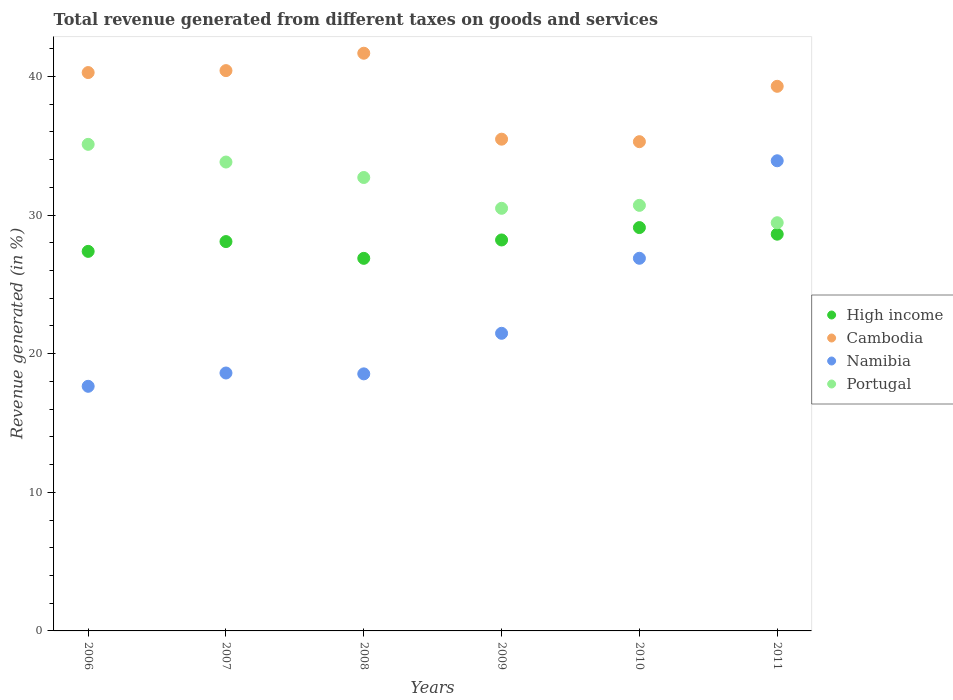Is the number of dotlines equal to the number of legend labels?
Ensure brevity in your answer.  Yes. What is the total revenue generated in High income in 2011?
Give a very brief answer. 28.62. Across all years, what is the maximum total revenue generated in High income?
Offer a very short reply. 29.09. Across all years, what is the minimum total revenue generated in Portugal?
Give a very brief answer. 29.44. In which year was the total revenue generated in High income minimum?
Your answer should be compact. 2008. What is the total total revenue generated in High income in the graph?
Keep it short and to the point. 168.25. What is the difference between the total revenue generated in Portugal in 2008 and that in 2010?
Provide a succinct answer. 2.01. What is the difference between the total revenue generated in High income in 2011 and the total revenue generated in Namibia in 2008?
Offer a terse response. 10.08. What is the average total revenue generated in High income per year?
Offer a terse response. 28.04. In the year 2006, what is the difference between the total revenue generated in High income and total revenue generated in Portugal?
Provide a succinct answer. -7.72. In how many years, is the total revenue generated in Namibia greater than 34 %?
Keep it short and to the point. 0. What is the ratio of the total revenue generated in High income in 2009 to that in 2011?
Your answer should be very brief. 0.99. Is the total revenue generated in Cambodia in 2006 less than that in 2008?
Give a very brief answer. Yes. What is the difference between the highest and the second highest total revenue generated in Portugal?
Give a very brief answer. 1.28. What is the difference between the highest and the lowest total revenue generated in Namibia?
Your response must be concise. 16.27. Is it the case that in every year, the sum of the total revenue generated in Namibia and total revenue generated in Portugal  is greater than the sum of total revenue generated in Cambodia and total revenue generated in High income?
Give a very brief answer. No. Is it the case that in every year, the sum of the total revenue generated in Portugal and total revenue generated in Namibia  is greater than the total revenue generated in High income?
Provide a succinct answer. Yes. How many years are there in the graph?
Your response must be concise. 6. Does the graph contain grids?
Ensure brevity in your answer.  No. How are the legend labels stacked?
Your answer should be very brief. Vertical. What is the title of the graph?
Keep it short and to the point. Total revenue generated from different taxes on goods and services. Does "Japan" appear as one of the legend labels in the graph?
Ensure brevity in your answer.  No. What is the label or title of the X-axis?
Your answer should be very brief. Years. What is the label or title of the Y-axis?
Ensure brevity in your answer.  Revenue generated (in %). What is the Revenue generated (in %) of High income in 2006?
Provide a short and direct response. 27.38. What is the Revenue generated (in %) of Cambodia in 2006?
Your response must be concise. 40.28. What is the Revenue generated (in %) in Namibia in 2006?
Ensure brevity in your answer.  17.65. What is the Revenue generated (in %) in Portugal in 2006?
Your answer should be very brief. 35.1. What is the Revenue generated (in %) in High income in 2007?
Provide a succinct answer. 28.08. What is the Revenue generated (in %) of Cambodia in 2007?
Keep it short and to the point. 40.42. What is the Revenue generated (in %) in Namibia in 2007?
Your response must be concise. 18.6. What is the Revenue generated (in %) of Portugal in 2007?
Provide a succinct answer. 33.82. What is the Revenue generated (in %) in High income in 2008?
Your answer should be very brief. 26.87. What is the Revenue generated (in %) in Cambodia in 2008?
Your answer should be compact. 41.67. What is the Revenue generated (in %) of Namibia in 2008?
Ensure brevity in your answer.  18.54. What is the Revenue generated (in %) of Portugal in 2008?
Give a very brief answer. 32.71. What is the Revenue generated (in %) in High income in 2009?
Offer a terse response. 28.2. What is the Revenue generated (in %) in Cambodia in 2009?
Give a very brief answer. 35.47. What is the Revenue generated (in %) of Namibia in 2009?
Offer a terse response. 21.47. What is the Revenue generated (in %) of Portugal in 2009?
Your answer should be very brief. 30.48. What is the Revenue generated (in %) in High income in 2010?
Make the answer very short. 29.09. What is the Revenue generated (in %) of Cambodia in 2010?
Offer a very short reply. 35.29. What is the Revenue generated (in %) of Namibia in 2010?
Ensure brevity in your answer.  26.88. What is the Revenue generated (in %) of Portugal in 2010?
Give a very brief answer. 30.7. What is the Revenue generated (in %) of High income in 2011?
Keep it short and to the point. 28.62. What is the Revenue generated (in %) of Cambodia in 2011?
Provide a short and direct response. 39.28. What is the Revenue generated (in %) in Namibia in 2011?
Ensure brevity in your answer.  33.91. What is the Revenue generated (in %) of Portugal in 2011?
Provide a succinct answer. 29.44. Across all years, what is the maximum Revenue generated (in %) in High income?
Make the answer very short. 29.09. Across all years, what is the maximum Revenue generated (in %) in Cambodia?
Offer a very short reply. 41.67. Across all years, what is the maximum Revenue generated (in %) of Namibia?
Offer a terse response. 33.91. Across all years, what is the maximum Revenue generated (in %) of Portugal?
Your answer should be very brief. 35.1. Across all years, what is the minimum Revenue generated (in %) in High income?
Give a very brief answer. 26.87. Across all years, what is the minimum Revenue generated (in %) in Cambodia?
Offer a very short reply. 35.29. Across all years, what is the minimum Revenue generated (in %) in Namibia?
Give a very brief answer. 17.65. Across all years, what is the minimum Revenue generated (in %) of Portugal?
Offer a very short reply. 29.44. What is the total Revenue generated (in %) of High income in the graph?
Give a very brief answer. 168.25. What is the total Revenue generated (in %) in Cambodia in the graph?
Ensure brevity in your answer.  232.41. What is the total Revenue generated (in %) in Namibia in the graph?
Ensure brevity in your answer.  137.05. What is the total Revenue generated (in %) of Portugal in the graph?
Offer a very short reply. 192.25. What is the difference between the Revenue generated (in %) of High income in 2006 and that in 2007?
Offer a very short reply. -0.71. What is the difference between the Revenue generated (in %) in Cambodia in 2006 and that in 2007?
Your answer should be very brief. -0.14. What is the difference between the Revenue generated (in %) of Namibia in 2006 and that in 2007?
Your answer should be compact. -0.96. What is the difference between the Revenue generated (in %) in Portugal in 2006 and that in 2007?
Offer a very short reply. 1.28. What is the difference between the Revenue generated (in %) of High income in 2006 and that in 2008?
Your response must be concise. 0.5. What is the difference between the Revenue generated (in %) of Cambodia in 2006 and that in 2008?
Offer a terse response. -1.39. What is the difference between the Revenue generated (in %) of Namibia in 2006 and that in 2008?
Your answer should be very brief. -0.9. What is the difference between the Revenue generated (in %) in Portugal in 2006 and that in 2008?
Your answer should be very brief. 2.39. What is the difference between the Revenue generated (in %) of High income in 2006 and that in 2009?
Offer a very short reply. -0.82. What is the difference between the Revenue generated (in %) of Cambodia in 2006 and that in 2009?
Ensure brevity in your answer.  4.8. What is the difference between the Revenue generated (in %) in Namibia in 2006 and that in 2009?
Your response must be concise. -3.82. What is the difference between the Revenue generated (in %) of Portugal in 2006 and that in 2009?
Give a very brief answer. 4.61. What is the difference between the Revenue generated (in %) in High income in 2006 and that in 2010?
Keep it short and to the point. -1.72. What is the difference between the Revenue generated (in %) of Cambodia in 2006 and that in 2010?
Ensure brevity in your answer.  4.99. What is the difference between the Revenue generated (in %) in Namibia in 2006 and that in 2010?
Offer a very short reply. -9.23. What is the difference between the Revenue generated (in %) in Portugal in 2006 and that in 2010?
Your answer should be very brief. 4.4. What is the difference between the Revenue generated (in %) of High income in 2006 and that in 2011?
Provide a short and direct response. -1.24. What is the difference between the Revenue generated (in %) of Cambodia in 2006 and that in 2011?
Offer a very short reply. 0.99. What is the difference between the Revenue generated (in %) in Namibia in 2006 and that in 2011?
Your answer should be very brief. -16.27. What is the difference between the Revenue generated (in %) in Portugal in 2006 and that in 2011?
Make the answer very short. 5.65. What is the difference between the Revenue generated (in %) of High income in 2007 and that in 2008?
Give a very brief answer. 1.21. What is the difference between the Revenue generated (in %) in Cambodia in 2007 and that in 2008?
Make the answer very short. -1.25. What is the difference between the Revenue generated (in %) of Namibia in 2007 and that in 2008?
Keep it short and to the point. 0.06. What is the difference between the Revenue generated (in %) in Portugal in 2007 and that in 2008?
Ensure brevity in your answer.  1.12. What is the difference between the Revenue generated (in %) in High income in 2007 and that in 2009?
Make the answer very short. -0.12. What is the difference between the Revenue generated (in %) in Cambodia in 2007 and that in 2009?
Keep it short and to the point. 4.95. What is the difference between the Revenue generated (in %) in Namibia in 2007 and that in 2009?
Give a very brief answer. -2.86. What is the difference between the Revenue generated (in %) in Portugal in 2007 and that in 2009?
Ensure brevity in your answer.  3.34. What is the difference between the Revenue generated (in %) in High income in 2007 and that in 2010?
Provide a succinct answer. -1.01. What is the difference between the Revenue generated (in %) in Cambodia in 2007 and that in 2010?
Provide a short and direct response. 5.13. What is the difference between the Revenue generated (in %) of Namibia in 2007 and that in 2010?
Ensure brevity in your answer.  -8.28. What is the difference between the Revenue generated (in %) in Portugal in 2007 and that in 2010?
Your answer should be very brief. 3.12. What is the difference between the Revenue generated (in %) of High income in 2007 and that in 2011?
Your answer should be compact. -0.53. What is the difference between the Revenue generated (in %) in Cambodia in 2007 and that in 2011?
Make the answer very short. 1.13. What is the difference between the Revenue generated (in %) in Namibia in 2007 and that in 2011?
Offer a terse response. -15.31. What is the difference between the Revenue generated (in %) in Portugal in 2007 and that in 2011?
Your answer should be compact. 4.38. What is the difference between the Revenue generated (in %) in High income in 2008 and that in 2009?
Offer a terse response. -1.33. What is the difference between the Revenue generated (in %) in Cambodia in 2008 and that in 2009?
Provide a succinct answer. 6.2. What is the difference between the Revenue generated (in %) of Namibia in 2008 and that in 2009?
Ensure brevity in your answer.  -2.93. What is the difference between the Revenue generated (in %) in Portugal in 2008 and that in 2009?
Your answer should be compact. 2.22. What is the difference between the Revenue generated (in %) of High income in 2008 and that in 2010?
Offer a very short reply. -2.22. What is the difference between the Revenue generated (in %) in Cambodia in 2008 and that in 2010?
Offer a terse response. 6.38. What is the difference between the Revenue generated (in %) of Namibia in 2008 and that in 2010?
Ensure brevity in your answer.  -8.34. What is the difference between the Revenue generated (in %) of Portugal in 2008 and that in 2010?
Provide a succinct answer. 2.01. What is the difference between the Revenue generated (in %) in High income in 2008 and that in 2011?
Make the answer very short. -1.74. What is the difference between the Revenue generated (in %) in Cambodia in 2008 and that in 2011?
Offer a very short reply. 2.39. What is the difference between the Revenue generated (in %) of Namibia in 2008 and that in 2011?
Your answer should be compact. -15.37. What is the difference between the Revenue generated (in %) of Portugal in 2008 and that in 2011?
Keep it short and to the point. 3.26. What is the difference between the Revenue generated (in %) of High income in 2009 and that in 2010?
Offer a very short reply. -0.89. What is the difference between the Revenue generated (in %) in Cambodia in 2009 and that in 2010?
Your response must be concise. 0.18. What is the difference between the Revenue generated (in %) of Namibia in 2009 and that in 2010?
Provide a short and direct response. -5.41. What is the difference between the Revenue generated (in %) of Portugal in 2009 and that in 2010?
Your answer should be very brief. -0.21. What is the difference between the Revenue generated (in %) of High income in 2009 and that in 2011?
Ensure brevity in your answer.  -0.42. What is the difference between the Revenue generated (in %) in Cambodia in 2009 and that in 2011?
Ensure brevity in your answer.  -3.81. What is the difference between the Revenue generated (in %) of Namibia in 2009 and that in 2011?
Offer a terse response. -12.44. What is the difference between the Revenue generated (in %) in Portugal in 2009 and that in 2011?
Offer a very short reply. 1.04. What is the difference between the Revenue generated (in %) of High income in 2010 and that in 2011?
Your answer should be compact. 0.48. What is the difference between the Revenue generated (in %) in Cambodia in 2010 and that in 2011?
Give a very brief answer. -3.99. What is the difference between the Revenue generated (in %) of Namibia in 2010 and that in 2011?
Your answer should be very brief. -7.03. What is the difference between the Revenue generated (in %) in Portugal in 2010 and that in 2011?
Make the answer very short. 1.25. What is the difference between the Revenue generated (in %) in High income in 2006 and the Revenue generated (in %) in Cambodia in 2007?
Provide a succinct answer. -13.04. What is the difference between the Revenue generated (in %) of High income in 2006 and the Revenue generated (in %) of Namibia in 2007?
Make the answer very short. 8.77. What is the difference between the Revenue generated (in %) of High income in 2006 and the Revenue generated (in %) of Portugal in 2007?
Offer a very short reply. -6.44. What is the difference between the Revenue generated (in %) of Cambodia in 2006 and the Revenue generated (in %) of Namibia in 2007?
Offer a very short reply. 21.67. What is the difference between the Revenue generated (in %) of Cambodia in 2006 and the Revenue generated (in %) of Portugal in 2007?
Offer a very short reply. 6.45. What is the difference between the Revenue generated (in %) of Namibia in 2006 and the Revenue generated (in %) of Portugal in 2007?
Provide a short and direct response. -16.18. What is the difference between the Revenue generated (in %) in High income in 2006 and the Revenue generated (in %) in Cambodia in 2008?
Ensure brevity in your answer.  -14.29. What is the difference between the Revenue generated (in %) of High income in 2006 and the Revenue generated (in %) of Namibia in 2008?
Ensure brevity in your answer.  8.84. What is the difference between the Revenue generated (in %) in High income in 2006 and the Revenue generated (in %) in Portugal in 2008?
Your answer should be very brief. -5.33. What is the difference between the Revenue generated (in %) in Cambodia in 2006 and the Revenue generated (in %) in Namibia in 2008?
Offer a very short reply. 21.73. What is the difference between the Revenue generated (in %) of Cambodia in 2006 and the Revenue generated (in %) of Portugal in 2008?
Ensure brevity in your answer.  7.57. What is the difference between the Revenue generated (in %) in Namibia in 2006 and the Revenue generated (in %) in Portugal in 2008?
Make the answer very short. -15.06. What is the difference between the Revenue generated (in %) in High income in 2006 and the Revenue generated (in %) in Cambodia in 2009?
Offer a terse response. -8.09. What is the difference between the Revenue generated (in %) in High income in 2006 and the Revenue generated (in %) in Namibia in 2009?
Provide a short and direct response. 5.91. What is the difference between the Revenue generated (in %) in High income in 2006 and the Revenue generated (in %) in Portugal in 2009?
Your response must be concise. -3.11. What is the difference between the Revenue generated (in %) in Cambodia in 2006 and the Revenue generated (in %) in Namibia in 2009?
Offer a very short reply. 18.81. What is the difference between the Revenue generated (in %) in Cambodia in 2006 and the Revenue generated (in %) in Portugal in 2009?
Keep it short and to the point. 9.79. What is the difference between the Revenue generated (in %) in Namibia in 2006 and the Revenue generated (in %) in Portugal in 2009?
Provide a succinct answer. -12.84. What is the difference between the Revenue generated (in %) of High income in 2006 and the Revenue generated (in %) of Cambodia in 2010?
Keep it short and to the point. -7.91. What is the difference between the Revenue generated (in %) of High income in 2006 and the Revenue generated (in %) of Namibia in 2010?
Provide a succinct answer. 0.5. What is the difference between the Revenue generated (in %) of High income in 2006 and the Revenue generated (in %) of Portugal in 2010?
Your answer should be compact. -3.32. What is the difference between the Revenue generated (in %) in Cambodia in 2006 and the Revenue generated (in %) in Namibia in 2010?
Provide a succinct answer. 13.4. What is the difference between the Revenue generated (in %) in Cambodia in 2006 and the Revenue generated (in %) in Portugal in 2010?
Give a very brief answer. 9.58. What is the difference between the Revenue generated (in %) in Namibia in 2006 and the Revenue generated (in %) in Portugal in 2010?
Provide a succinct answer. -13.05. What is the difference between the Revenue generated (in %) in High income in 2006 and the Revenue generated (in %) in Cambodia in 2011?
Make the answer very short. -11.91. What is the difference between the Revenue generated (in %) of High income in 2006 and the Revenue generated (in %) of Namibia in 2011?
Give a very brief answer. -6.54. What is the difference between the Revenue generated (in %) in High income in 2006 and the Revenue generated (in %) in Portugal in 2011?
Your response must be concise. -2.07. What is the difference between the Revenue generated (in %) of Cambodia in 2006 and the Revenue generated (in %) of Namibia in 2011?
Keep it short and to the point. 6.36. What is the difference between the Revenue generated (in %) of Cambodia in 2006 and the Revenue generated (in %) of Portugal in 2011?
Offer a very short reply. 10.83. What is the difference between the Revenue generated (in %) of Namibia in 2006 and the Revenue generated (in %) of Portugal in 2011?
Ensure brevity in your answer.  -11.8. What is the difference between the Revenue generated (in %) in High income in 2007 and the Revenue generated (in %) in Cambodia in 2008?
Offer a very short reply. -13.59. What is the difference between the Revenue generated (in %) in High income in 2007 and the Revenue generated (in %) in Namibia in 2008?
Your answer should be compact. 9.54. What is the difference between the Revenue generated (in %) in High income in 2007 and the Revenue generated (in %) in Portugal in 2008?
Give a very brief answer. -4.62. What is the difference between the Revenue generated (in %) in Cambodia in 2007 and the Revenue generated (in %) in Namibia in 2008?
Keep it short and to the point. 21.87. What is the difference between the Revenue generated (in %) in Cambodia in 2007 and the Revenue generated (in %) in Portugal in 2008?
Your response must be concise. 7.71. What is the difference between the Revenue generated (in %) in Namibia in 2007 and the Revenue generated (in %) in Portugal in 2008?
Ensure brevity in your answer.  -14.1. What is the difference between the Revenue generated (in %) in High income in 2007 and the Revenue generated (in %) in Cambodia in 2009?
Offer a very short reply. -7.39. What is the difference between the Revenue generated (in %) in High income in 2007 and the Revenue generated (in %) in Namibia in 2009?
Make the answer very short. 6.62. What is the difference between the Revenue generated (in %) in High income in 2007 and the Revenue generated (in %) in Portugal in 2009?
Ensure brevity in your answer.  -2.4. What is the difference between the Revenue generated (in %) in Cambodia in 2007 and the Revenue generated (in %) in Namibia in 2009?
Keep it short and to the point. 18.95. What is the difference between the Revenue generated (in %) in Cambodia in 2007 and the Revenue generated (in %) in Portugal in 2009?
Your answer should be compact. 9.93. What is the difference between the Revenue generated (in %) in Namibia in 2007 and the Revenue generated (in %) in Portugal in 2009?
Provide a short and direct response. -11.88. What is the difference between the Revenue generated (in %) of High income in 2007 and the Revenue generated (in %) of Cambodia in 2010?
Ensure brevity in your answer.  -7.21. What is the difference between the Revenue generated (in %) of High income in 2007 and the Revenue generated (in %) of Namibia in 2010?
Give a very brief answer. 1.2. What is the difference between the Revenue generated (in %) in High income in 2007 and the Revenue generated (in %) in Portugal in 2010?
Offer a very short reply. -2.61. What is the difference between the Revenue generated (in %) in Cambodia in 2007 and the Revenue generated (in %) in Namibia in 2010?
Offer a terse response. 13.54. What is the difference between the Revenue generated (in %) of Cambodia in 2007 and the Revenue generated (in %) of Portugal in 2010?
Offer a terse response. 9.72. What is the difference between the Revenue generated (in %) of Namibia in 2007 and the Revenue generated (in %) of Portugal in 2010?
Ensure brevity in your answer.  -12.09. What is the difference between the Revenue generated (in %) in High income in 2007 and the Revenue generated (in %) in Cambodia in 2011?
Keep it short and to the point. -11.2. What is the difference between the Revenue generated (in %) of High income in 2007 and the Revenue generated (in %) of Namibia in 2011?
Offer a terse response. -5.83. What is the difference between the Revenue generated (in %) of High income in 2007 and the Revenue generated (in %) of Portugal in 2011?
Provide a short and direct response. -1.36. What is the difference between the Revenue generated (in %) in Cambodia in 2007 and the Revenue generated (in %) in Namibia in 2011?
Your answer should be very brief. 6.5. What is the difference between the Revenue generated (in %) of Cambodia in 2007 and the Revenue generated (in %) of Portugal in 2011?
Your answer should be very brief. 10.97. What is the difference between the Revenue generated (in %) of Namibia in 2007 and the Revenue generated (in %) of Portugal in 2011?
Give a very brief answer. -10.84. What is the difference between the Revenue generated (in %) in High income in 2008 and the Revenue generated (in %) in Cambodia in 2009?
Provide a succinct answer. -8.6. What is the difference between the Revenue generated (in %) in High income in 2008 and the Revenue generated (in %) in Namibia in 2009?
Provide a short and direct response. 5.41. What is the difference between the Revenue generated (in %) in High income in 2008 and the Revenue generated (in %) in Portugal in 2009?
Make the answer very short. -3.61. What is the difference between the Revenue generated (in %) in Cambodia in 2008 and the Revenue generated (in %) in Namibia in 2009?
Keep it short and to the point. 20.2. What is the difference between the Revenue generated (in %) of Cambodia in 2008 and the Revenue generated (in %) of Portugal in 2009?
Keep it short and to the point. 11.19. What is the difference between the Revenue generated (in %) in Namibia in 2008 and the Revenue generated (in %) in Portugal in 2009?
Your response must be concise. -11.94. What is the difference between the Revenue generated (in %) in High income in 2008 and the Revenue generated (in %) in Cambodia in 2010?
Offer a terse response. -8.42. What is the difference between the Revenue generated (in %) of High income in 2008 and the Revenue generated (in %) of Namibia in 2010?
Provide a short and direct response. -0.01. What is the difference between the Revenue generated (in %) of High income in 2008 and the Revenue generated (in %) of Portugal in 2010?
Keep it short and to the point. -3.82. What is the difference between the Revenue generated (in %) of Cambodia in 2008 and the Revenue generated (in %) of Namibia in 2010?
Make the answer very short. 14.79. What is the difference between the Revenue generated (in %) in Cambodia in 2008 and the Revenue generated (in %) in Portugal in 2010?
Keep it short and to the point. 10.97. What is the difference between the Revenue generated (in %) in Namibia in 2008 and the Revenue generated (in %) in Portugal in 2010?
Your answer should be compact. -12.16. What is the difference between the Revenue generated (in %) of High income in 2008 and the Revenue generated (in %) of Cambodia in 2011?
Offer a very short reply. -12.41. What is the difference between the Revenue generated (in %) in High income in 2008 and the Revenue generated (in %) in Namibia in 2011?
Your answer should be very brief. -7.04. What is the difference between the Revenue generated (in %) in High income in 2008 and the Revenue generated (in %) in Portugal in 2011?
Make the answer very short. -2.57. What is the difference between the Revenue generated (in %) in Cambodia in 2008 and the Revenue generated (in %) in Namibia in 2011?
Offer a very short reply. 7.76. What is the difference between the Revenue generated (in %) of Cambodia in 2008 and the Revenue generated (in %) of Portugal in 2011?
Provide a short and direct response. 12.23. What is the difference between the Revenue generated (in %) in Namibia in 2008 and the Revenue generated (in %) in Portugal in 2011?
Provide a short and direct response. -10.9. What is the difference between the Revenue generated (in %) in High income in 2009 and the Revenue generated (in %) in Cambodia in 2010?
Provide a succinct answer. -7.09. What is the difference between the Revenue generated (in %) of High income in 2009 and the Revenue generated (in %) of Namibia in 2010?
Offer a very short reply. 1.32. What is the difference between the Revenue generated (in %) of High income in 2009 and the Revenue generated (in %) of Portugal in 2010?
Your answer should be compact. -2.5. What is the difference between the Revenue generated (in %) of Cambodia in 2009 and the Revenue generated (in %) of Namibia in 2010?
Provide a short and direct response. 8.59. What is the difference between the Revenue generated (in %) in Cambodia in 2009 and the Revenue generated (in %) in Portugal in 2010?
Provide a short and direct response. 4.77. What is the difference between the Revenue generated (in %) in Namibia in 2009 and the Revenue generated (in %) in Portugal in 2010?
Your answer should be very brief. -9.23. What is the difference between the Revenue generated (in %) of High income in 2009 and the Revenue generated (in %) of Cambodia in 2011?
Offer a terse response. -11.08. What is the difference between the Revenue generated (in %) in High income in 2009 and the Revenue generated (in %) in Namibia in 2011?
Give a very brief answer. -5.71. What is the difference between the Revenue generated (in %) in High income in 2009 and the Revenue generated (in %) in Portugal in 2011?
Your answer should be very brief. -1.24. What is the difference between the Revenue generated (in %) of Cambodia in 2009 and the Revenue generated (in %) of Namibia in 2011?
Keep it short and to the point. 1.56. What is the difference between the Revenue generated (in %) of Cambodia in 2009 and the Revenue generated (in %) of Portugal in 2011?
Provide a short and direct response. 6.03. What is the difference between the Revenue generated (in %) in Namibia in 2009 and the Revenue generated (in %) in Portugal in 2011?
Make the answer very short. -7.98. What is the difference between the Revenue generated (in %) of High income in 2010 and the Revenue generated (in %) of Cambodia in 2011?
Your response must be concise. -10.19. What is the difference between the Revenue generated (in %) of High income in 2010 and the Revenue generated (in %) of Namibia in 2011?
Offer a very short reply. -4.82. What is the difference between the Revenue generated (in %) of High income in 2010 and the Revenue generated (in %) of Portugal in 2011?
Offer a terse response. -0.35. What is the difference between the Revenue generated (in %) of Cambodia in 2010 and the Revenue generated (in %) of Namibia in 2011?
Provide a succinct answer. 1.38. What is the difference between the Revenue generated (in %) of Cambodia in 2010 and the Revenue generated (in %) of Portugal in 2011?
Offer a very short reply. 5.85. What is the difference between the Revenue generated (in %) in Namibia in 2010 and the Revenue generated (in %) in Portugal in 2011?
Make the answer very short. -2.56. What is the average Revenue generated (in %) in High income per year?
Your answer should be compact. 28.04. What is the average Revenue generated (in %) in Cambodia per year?
Your answer should be very brief. 38.73. What is the average Revenue generated (in %) in Namibia per year?
Offer a terse response. 22.84. What is the average Revenue generated (in %) of Portugal per year?
Offer a terse response. 32.04. In the year 2006, what is the difference between the Revenue generated (in %) of High income and Revenue generated (in %) of Cambodia?
Keep it short and to the point. -12.9. In the year 2006, what is the difference between the Revenue generated (in %) of High income and Revenue generated (in %) of Namibia?
Offer a very short reply. 9.73. In the year 2006, what is the difference between the Revenue generated (in %) of High income and Revenue generated (in %) of Portugal?
Ensure brevity in your answer.  -7.72. In the year 2006, what is the difference between the Revenue generated (in %) of Cambodia and Revenue generated (in %) of Namibia?
Ensure brevity in your answer.  22.63. In the year 2006, what is the difference between the Revenue generated (in %) in Cambodia and Revenue generated (in %) in Portugal?
Offer a terse response. 5.18. In the year 2006, what is the difference between the Revenue generated (in %) in Namibia and Revenue generated (in %) in Portugal?
Give a very brief answer. -17.45. In the year 2007, what is the difference between the Revenue generated (in %) in High income and Revenue generated (in %) in Cambodia?
Provide a succinct answer. -12.33. In the year 2007, what is the difference between the Revenue generated (in %) in High income and Revenue generated (in %) in Namibia?
Your answer should be compact. 9.48. In the year 2007, what is the difference between the Revenue generated (in %) of High income and Revenue generated (in %) of Portugal?
Your answer should be very brief. -5.74. In the year 2007, what is the difference between the Revenue generated (in %) of Cambodia and Revenue generated (in %) of Namibia?
Keep it short and to the point. 21.81. In the year 2007, what is the difference between the Revenue generated (in %) in Cambodia and Revenue generated (in %) in Portugal?
Give a very brief answer. 6.59. In the year 2007, what is the difference between the Revenue generated (in %) of Namibia and Revenue generated (in %) of Portugal?
Your answer should be very brief. -15.22. In the year 2008, what is the difference between the Revenue generated (in %) in High income and Revenue generated (in %) in Cambodia?
Your response must be concise. -14.8. In the year 2008, what is the difference between the Revenue generated (in %) of High income and Revenue generated (in %) of Namibia?
Offer a terse response. 8.33. In the year 2008, what is the difference between the Revenue generated (in %) of High income and Revenue generated (in %) of Portugal?
Provide a short and direct response. -5.83. In the year 2008, what is the difference between the Revenue generated (in %) in Cambodia and Revenue generated (in %) in Namibia?
Offer a very short reply. 23.13. In the year 2008, what is the difference between the Revenue generated (in %) of Cambodia and Revenue generated (in %) of Portugal?
Offer a terse response. 8.96. In the year 2008, what is the difference between the Revenue generated (in %) in Namibia and Revenue generated (in %) in Portugal?
Your answer should be very brief. -14.16. In the year 2009, what is the difference between the Revenue generated (in %) of High income and Revenue generated (in %) of Cambodia?
Provide a short and direct response. -7.27. In the year 2009, what is the difference between the Revenue generated (in %) in High income and Revenue generated (in %) in Namibia?
Make the answer very short. 6.73. In the year 2009, what is the difference between the Revenue generated (in %) of High income and Revenue generated (in %) of Portugal?
Your answer should be compact. -2.28. In the year 2009, what is the difference between the Revenue generated (in %) in Cambodia and Revenue generated (in %) in Namibia?
Provide a short and direct response. 14. In the year 2009, what is the difference between the Revenue generated (in %) of Cambodia and Revenue generated (in %) of Portugal?
Provide a succinct answer. 4.99. In the year 2009, what is the difference between the Revenue generated (in %) in Namibia and Revenue generated (in %) in Portugal?
Offer a terse response. -9.02. In the year 2010, what is the difference between the Revenue generated (in %) of High income and Revenue generated (in %) of Cambodia?
Make the answer very short. -6.2. In the year 2010, what is the difference between the Revenue generated (in %) in High income and Revenue generated (in %) in Namibia?
Your answer should be very brief. 2.21. In the year 2010, what is the difference between the Revenue generated (in %) in High income and Revenue generated (in %) in Portugal?
Your response must be concise. -1.6. In the year 2010, what is the difference between the Revenue generated (in %) in Cambodia and Revenue generated (in %) in Namibia?
Provide a succinct answer. 8.41. In the year 2010, what is the difference between the Revenue generated (in %) in Cambodia and Revenue generated (in %) in Portugal?
Provide a succinct answer. 4.59. In the year 2010, what is the difference between the Revenue generated (in %) of Namibia and Revenue generated (in %) of Portugal?
Make the answer very short. -3.82. In the year 2011, what is the difference between the Revenue generated (in %) in High income and Revenue generated (in %) in Cambodia?
Offer a very short reply. -10.67. In the year 2011, what is the difference between the Revenue generated (in %) of High income and Revenue generated (in %) of Namibia?
Offer a very short reply. -5.3. In the year 2011, what is the difference between the Revenue generated (in %) of High income and Revenue generated (in %) of Portugal?
Make the answer very short. -0.83. In the year 2011, what is the difference between the Revenue generated (in %) in Cambodia and Revenue generated (in %) in Namibia?
Keep it short and to the point. 5.37. In the year 2011, what is the difference between the Revenue generated (in %) in Cambodia and Revenue generated (in %) in Portugal?
Keep it short and to the point. 9.84. In the year 2011, what is the difference between the Revenue generated (in %) of Namibia and Revenue generated (in %) of Portugal?
Your answer should be very brief. 4.47. What is the ratio of the Revenue generated (in %) in High income in 2006 to that in 2007?
Your answer should be compact. 0.97. What is the ratio of the Revenue generated (in %) in Cambodia in 2006 to that in 2007?
Your response must be concise. 1. What is the ratio of the Revenue generated (in %) in Namibia in 2006 to that in 2007?
Make the answer very short. 0.95. What is the ratio of the Revenue generated (in %) in Portugal in 2006 to that in 2007?
Your response must be concise. 1.04. What is the ratio of the Revenue generated (in %) in High income in 2006 to that in 2008?
Give a very brief answer. 1.02. What is the ratio of the Revenue generated (in %) in Cambodia in 2006 to that in 2008?
Offer a terse response. 0.97. What is the ratio of the Revenue generated (in %) of Namibia in 2006 to that in 2008?
Give a very brief answer. 0.95. What is the ratio of the Revenue generated (in %) of Portugal in 2006 to that in 2008?
Make the answer very short. 1.07. What is the ratio of the Revenue generated (in %) in High income in 2006 to that in 2009?
Your answer should be very brief. 0.97. What is the ratio of the Revenue generated (in %) of Cambodia in 2006 to that in 2009?
Ensure brevity in your answer.  1.14. What is the ratio of the Revenue generated (in %) in Namibia in 2006 to that in 2009?
Your answer should be very brief. 0.82. What is the ratio of the Revenue generated (in %) of Portugal in 2006 to that in 2009?
Offer a very short reply. 1.15. What is the ratio of the Revenue generated (in %) in High income in 2006 to that in 2010?
Offer a very short reply. 0.94. What is the ratio of the Revenue generated (in %) of Cambodia in 2006 to that in 2010?
Your answer should be compact. 1.14. What is the ratio of the Revenue generated (in %) of Namibia in 2006 to that in 2010?
Your response must be concise. 0.66. What is the ratio of the Revenue generated (in %) of Portugal in 2006 to that in 2010?
Ensure brevity in your answer.  1.14. What is the ratio of the Revenue generated (in %) in High income in 2006 to that in 2011?
Offer a very short reply. 0.96. What is the ratio of the Revenue generated (in %) in Cambodia in 2006 to that in 2011?
Offer a terse response. 1.03. What is the ratio of the Revenue generated (in %) in Namibia in 2006 to that in 2011?
Make the answer very short. 0.52. What is the ratio of the Revenue generated (in %) in Portugal in 2006 to that in 2011?
Your response must be concise. 1.19. What is the ratio of the Revenue generated (in %) in High income in 2007 to that in 2008?
Your answer should be compact. 1.04. What is the ratio of the Revenue generated (in %) in Cambodia in 2007 to that in 2008?
Your response must be concise. 0.97. What is the ratio of the Revenue generated (in %) of Namibia in 2007 to that in 2008?
Provide a short and direct response. 1. What is the ratio of the Revenue generated (in %) in Portugal in 2007 to that in 2008?
Your answer should be compact. 1.03. What is the ratio of the Revenue generated (in %) of Cambodia in 2007 to that in 2009?
Your answer should be very brief. 1.14. What is the ratio of the Revenue generated (in %) in Namibia in 2007 to that in 2009?
Offer a very short reply. 0.87. What is the ratio of the Revenue generated (in %) of Portugal in 2007 to that in 2009?
Ensure brevity in your answer.  1.11. What is the ratio of the Revenue generated (in %) in High income in 2007 to that in 2010?
Ensure brevity in your answer.  0.97. What is the ratio of the Revenue generated (in %) in Cambodia in 2007 to that in 2010?
Ensure brevity in your answer.  1.15. What is the ratio of the Revenue generated (in %) of Namibia in 2007 to that in 2010?
Ensure brevity in your answer.  0.69. What is the ratio of the Revenue generated (in %) of Portugal in 2007 to that in 2010?
Your answer should be compact. 1.1. What is the ratio of the Revenue generated (in %) of High income in 2007 to that in 2011?
Make the answer very short. 0.98. What is the ratio of the Revenue generated (in %) in Cambodia in 2007 to that in 2011?
Your answer should be compact. 1.03. What is the ratio of the Revenue generated (in %) of Namibia in 2007 to that in 2011?
Keep it short and to the point. 0.55. What is the ratio of the Revenue generated (in %) in Portugal in 2007 to that in 2011?
Keep it short and to the point. 1.15. What is the ratio of the Revenue generated (in %) in High income in 2008 to that in 2009?
Your answer should be very brief. 0.95. What is the ratio of the Revenue generated (in %) of Cambodia in 2008 to that in 2009?
Provide a short and direct response. 1.17. What is the ratio of the Revenue generated (in %) of Namibia in 2008 to that in 2009?
Offer a very short reply. 0.86. What is the ratio of the Revenue generated (in %) in Portugal in 2008 to that in 2009?
Give a very brief answer. 1.07. What is the ratio of the Revenue generated (in %) in High income in 2008 to that in 2010?
Offer a very short reply. 0.92. What is the ratio of the Revenue generated (in %) in Cambodia in 2008 to that in 2010?
Keep it short and to the point. 1.18. What is the ratio of the Revenue generated (in %) in Namibia in 2008 to that in 2010?
Your response must be concise. 0.69. What is the ratio of the Revenue generated (in %) of Portugal in 2008 to that in 2010?
Offer a very short reply. 1.07. What is the ratio of the Revenue generated (in %) of High income in 2008 to that in 2011?
Offer a very short reply. 0.94. What is the ratio of the Revenue generated (in %) in Cambodia in 2008 to that in 2011?
Provide a succinct answer. 1.06. What is the ratio of the Revenue generated (in %) in Namibia in 2008 to that in 2011?
Give a very brief answer. 0.55. What is the ratio of the Revenue generated (in %) in Portugal in 2008 to that in 2011?
Your answer should be very brief. 1.11. What is the ratio of the Revenue generated (in %) of High income in 2009 to that in 2010?
Your response must be concise. 0.97. What is the ratio of the Revenue generated (in %) of Cambodia in 2009 to that in 2010?
Ensure brevity in your answer.  1.01. What is the ratio of the Revenue generated (in %) in Namibia in 2009 to that in 2010?
Provide a short and direct response. 0.8. What is the ratio of the Revenue generated (in %) in High income in 2009 to that in 2011?
Your response must be concise. 0.99. What is the ratio of the Revenue generated (in %) of Cambodia in 2009 to that in 2011?
Your answer should be very brief. 0.9. What is the ratio of the Revenue generated (in %) of Namibia in 2009 to that in 2011?
Give a very brief answer. 0.63. What is the ratio of the Revenue generated (in %) in Portugal in 2009 to that in 2011?
Your answer should be compact. 1.04. What is the ratio of the Revenue generated (in %) of High income in 2010 to that in 2011?
Your answer should be very brief. 1.02. What is the ratio of the Revenue generated (in %) in Cambodia in 2010 to that in 2011?
Provide a succinct answer. 0.9. What is the ratio of the Revenue generated (in %) of Namibia in 2010 to that in 2011?
Give a very brief answer. 0.79. What is the ratio of the Revenue generated (in %) of Portugal in 2010 to that in 2011?
Provide a succinct answer. 1.04. What is the difference between the highest and the second highest Revenue generated (in %) of High income?
Offer a very short reply. 0.48. What is the difference between the highest and the second highest Revenue generated (in %) in Cambodia?
Provide a short and direct response. 1.25. What is the difference between the highest and the second highest Revenue generated (in %) in Namibia?
Make the answer very short. 7.03. What is the difference between the highest and the second highest Revenue generated (in %) in Portugal?
Your answer should be very brief. 1.28. What is the difference between the highest and the lowest Revenue generated (in %) of High income?
Offer a very short reply. 2.22. What is the difference between the highest and the lowest Revenue generated (in %) of Cambodia?
Ensure brevity in your answer.  6.38. What is the difference between the highest and the lowest Revenue generated (in %) of Namibia?
Make the answer very short. 16.27. What is the difference between the highest and the lowest Revenue generated (in %) of Portugal?
Make the answer very short. 5.65. 